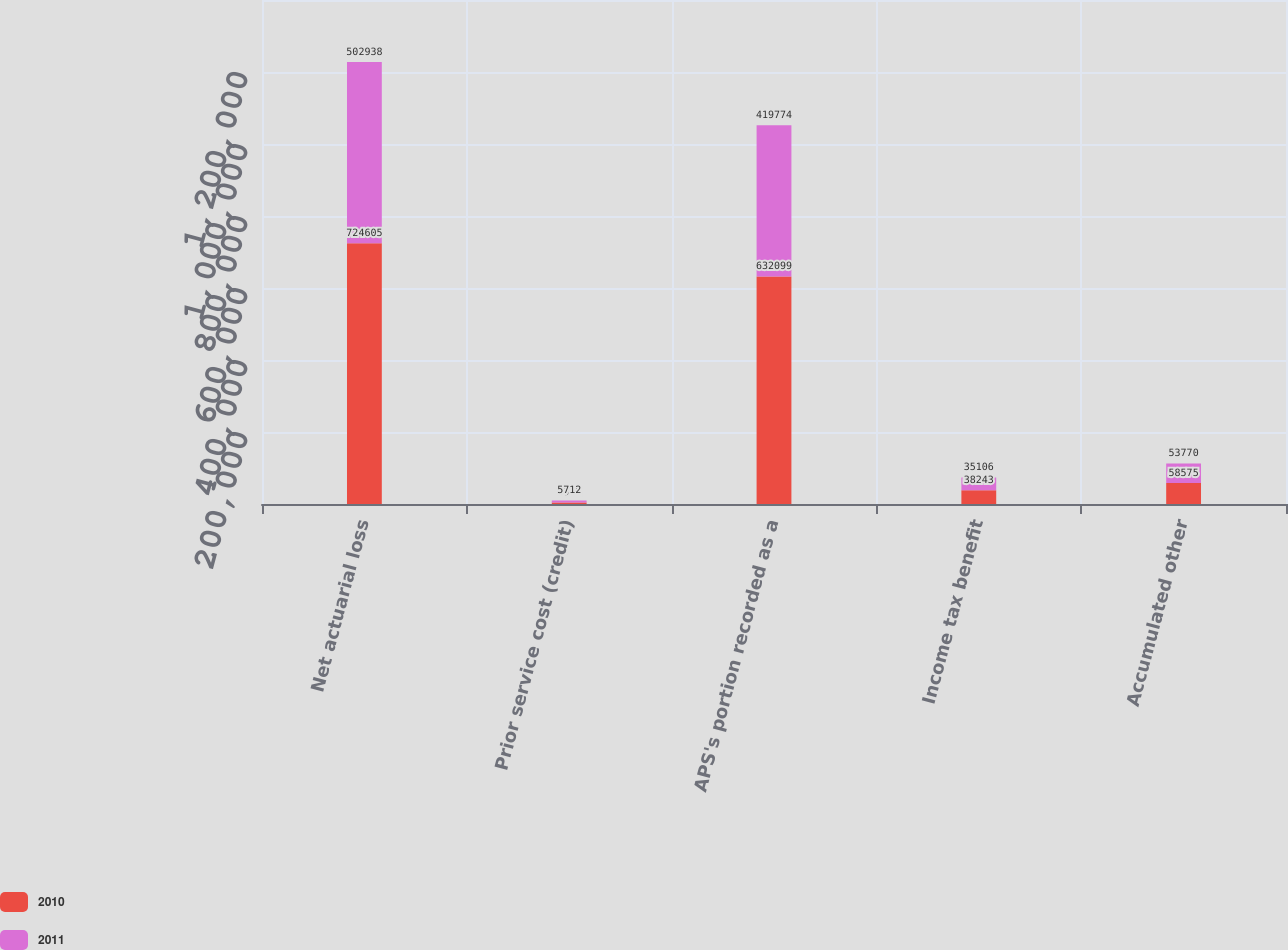<chart> <loc_0><loc_0><loc_500><loc_500><stacked_bar_chart><ecel><fcel>Net actuarial loss<fcel>Prior service cost (credit)<fcel>APS's portion recorded as a<fcel>Income tax benefit<fcel>Accumulated other<nl><fcel>2010<fcel>724605<fcel>4312<fcel>632099<fcel>38243<fcel>58575<nl><fcel>2011<fcel>502938<fcel>5712<fcel>419774<fcel>35106<fcel>53770<nl></chart> 